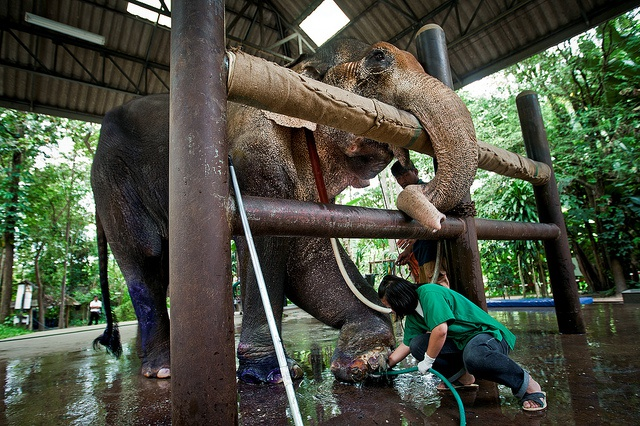Describe the objects in this image and their specific colors. I can see elephant in black, gray, and maroon tones, people in black, teal, and turquoise tones, people in black, maroon, and gray tones, people in black, maroon, gray, and ivory tones, and people in black, white, gray, and darkgreen tones in this image. 